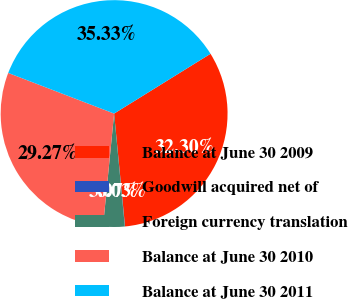Convert chart. <chart><loc_0><loc_0><loc_500><loc_500><pie_chart><fcel>Balance at June 30 2009<fcel>Goodwill acquired net of<fcel>Foreign currency translation<fcel>Balance at June 30 2010<fcel>Balance at June 30 2011<nl><fcel>32.3%<fcel>0.03%<fcel>3.07%<fcel>29.27%<fcel>35.33%<nl></chart> 